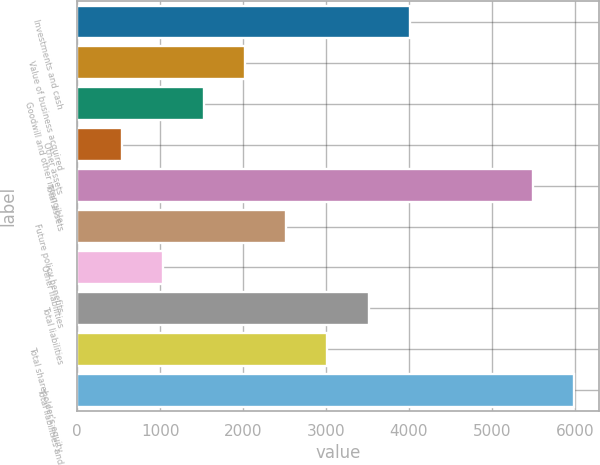Convert chart to OTSL. <chart><loc_0><loc_0><loc_500><loc_500><bar_chart><fcel>Investments and cash<fcel>Value of business acquired<fcel>Goodwill and other intangible<fcel>Other assets<fcel>Total assets<fcel>Future policy benefits<fcel>Other liabilities<fcel>Total liabilities<fcel>Total shareholder's equity<fcel>Total liabilities and<nl><fcel>4009.4<fcel>2024.6<fcel>1528.4<fcel>536<fcel>5498<fcel>2520.8<fcel>1032.2<fcel>3513.2<fcel>3017<fcel>5994.2<nl></chart> 